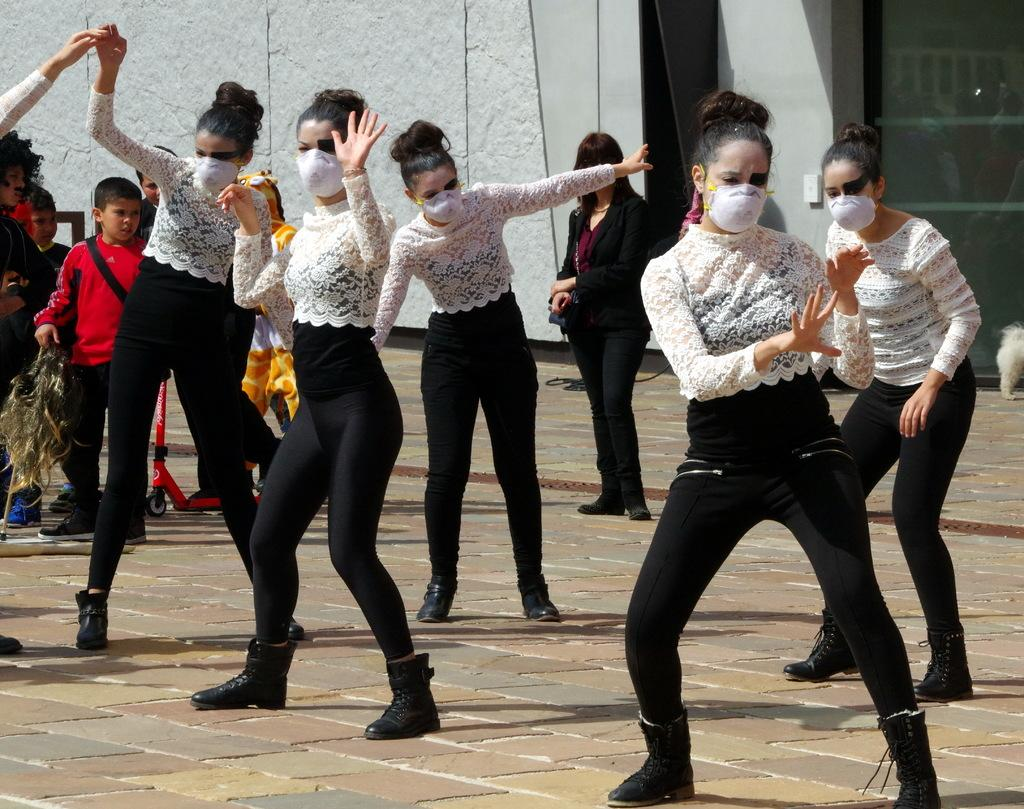What is happening in the image involving a group of women? There is a group of women performing in the image. Where is the performance taking place? The performance is taking place on the road. Can you describe any other people in the image? There is a person standing and watching the performance. What type of structures can be seen in the image? Walls and doors are present in the image. What type of trousers is the garden wearing in the image? There is no garden or trousers present in the image. How does the heat affect the performance in the image? The image does not provide any information about the temperature or heat, so it cannot be determined how it affects the performance. 